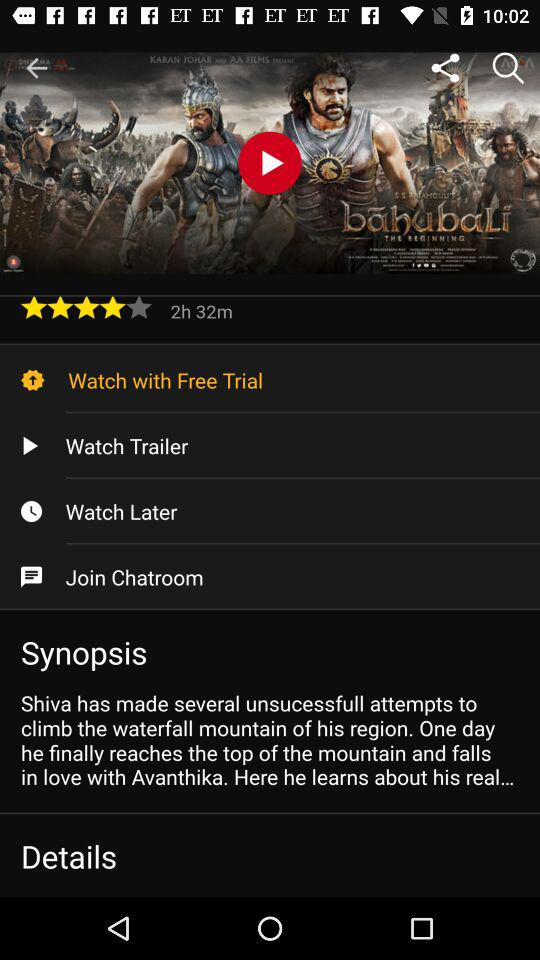What is the rating of the movie? The rating of the movie is 4 stars. 